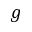<formula> <loc_0><loc_0><loc_500><loc_500>g</formula> 